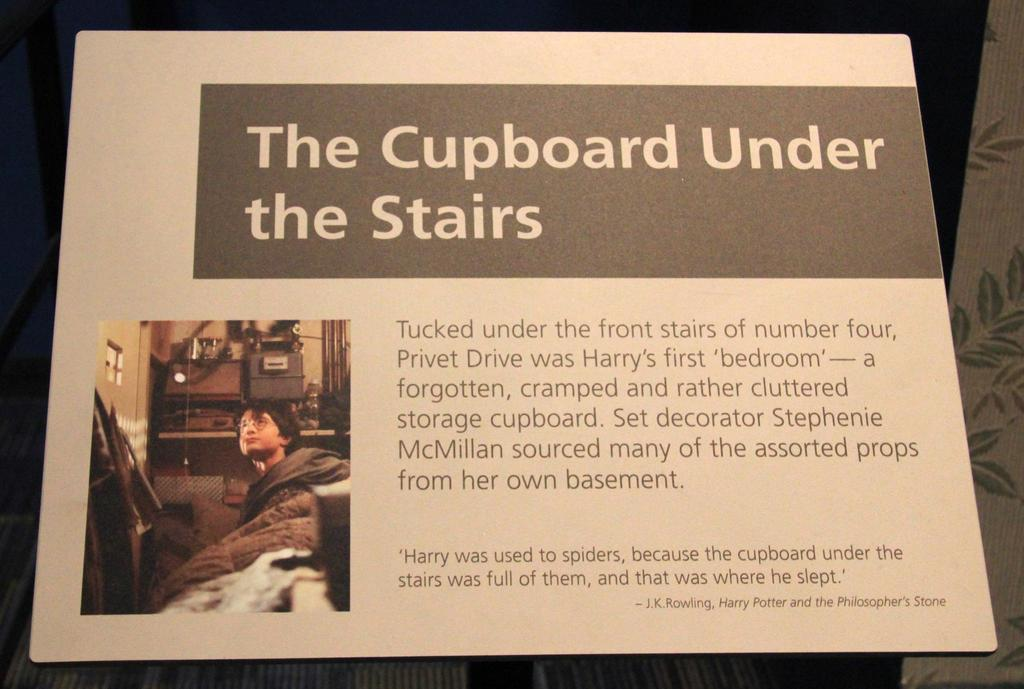<image>
Offer a succinct explanation of the picture presented. A passage that says the cupboard under the stairs 